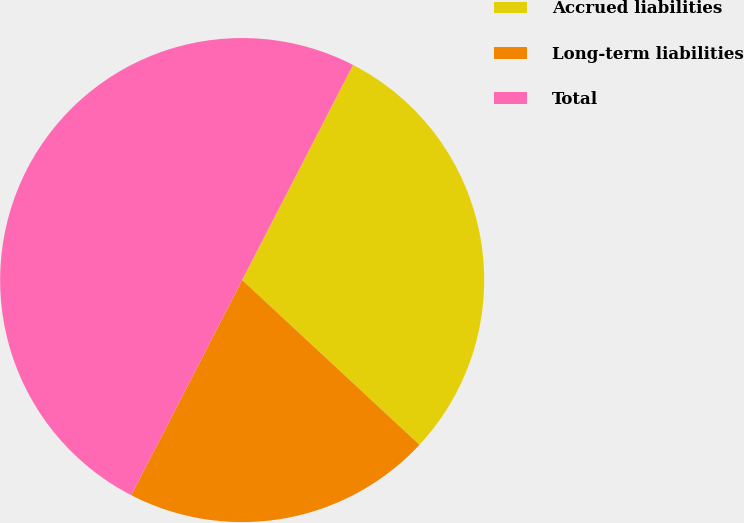Convert chart. <chart><loc_0><loc_0><loc_500><loc_500><pie_chart><fcel>Accrued liabilities<fcel>Long-term liabilities<fcel>Total<nl><fcel>29.34%<fcel>20.66%<fcel>50.0%<nl></chart> 